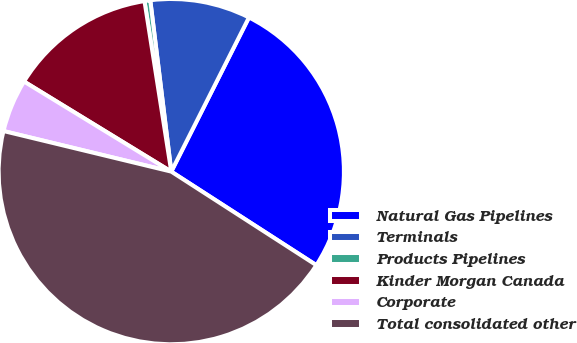Convert chart. <chart><loc_0><loc_0><loc_500><loc_500><pie_chart><fcel>Natural Gas Pipelines<fcel>Terminals<fcel>Products Pipelines<fcel>Kinder Morgan Canada<fcel>Corporate<fcel>Total consolidated other<nl><fcel>26.69%<fcel>9.37%<fcel>0.54%<fcel>13.78%<fcel>4.96%<fcel>44.66%<nl></chart> 